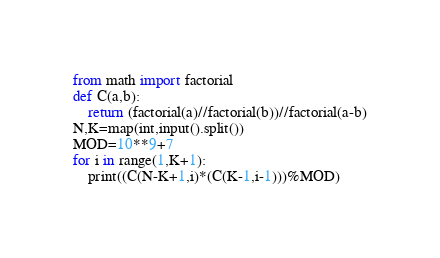<code> <loc_0><loc_0><loc_500><loc_500><_Python_>from math import factorial
def C(a,b):
    return (factorial(a)//factorial(b))//factorial(a-b)
N,K=map(int,input().split())
MOD=10**9+7
for i in range(1,K+1):
    print((C(N-K+1,i)*(C(K-1,i-1)))%MOD)</code> 